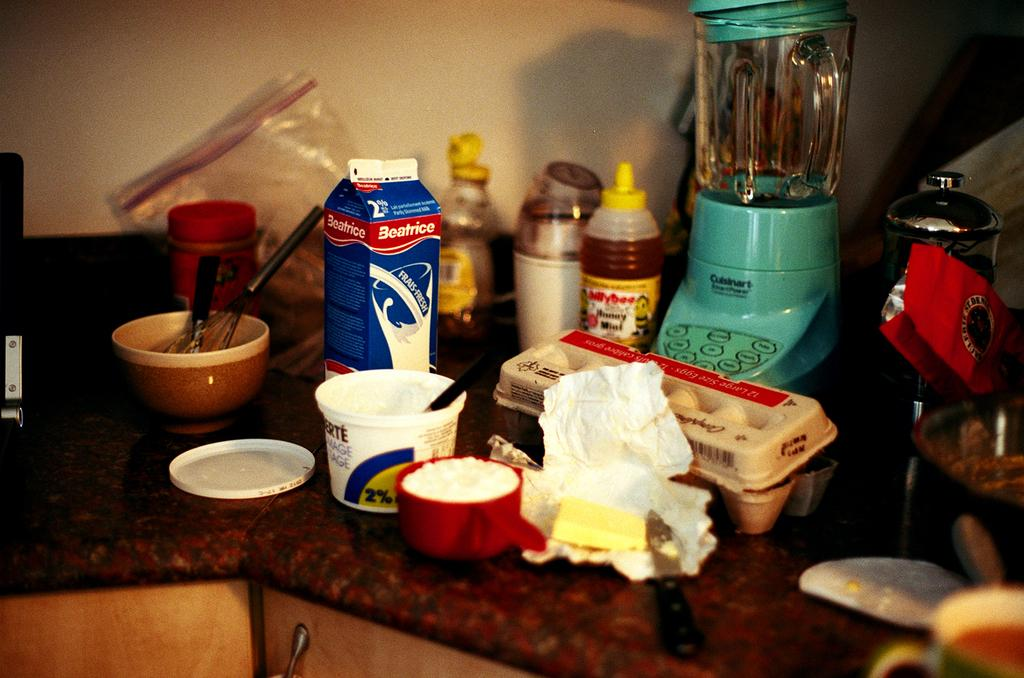<image>
Create a compact narrative representing the image presented. A counter top with several breakfast style items and a carton of Beatrice brand fresh milk. 